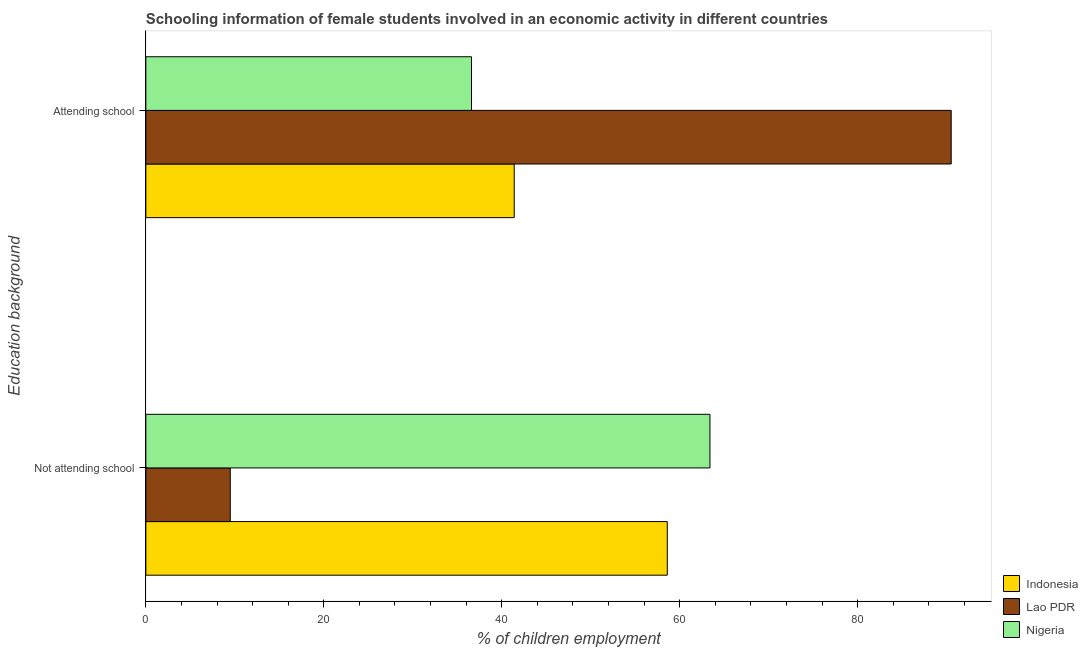How many different coloured bars are there?
Offer a very short reply. 3. How many groups of bars are there?
Your response must be concise. 2. Are the number of bars on each tick of the Y-axis equal?
Your response must be concise. Yes. What is the label of the 1st group of bars from the top?
Make the answer very short. Attending school. What is the percentage of employed females who are attending school in Nigeria?
Keep it short and to the point. 36.6. Across all countries, what is the maximum percentage of employed females who are attending school?
Offer a terse response. 90.51. Across all countries, what is the minimum percentage of employed females who are not attending school?
Make the answer very short. 9.49. In which country was the percentage of employed females who are attending school maximum?
Offer a very short reply. Lao PDR. In which country was the percentage of employed females who are attending school minimum?
Your answer should be compact. Nigeria. What is the total percentage of employed females who are attending school in the graph?
Your response must be concise. 168.51. What is the difference between the percentage of employed females who are not attending school in Nigeria and that in Lao PDR?
Offer a terse response. 53.91. What is the difference between the percentage of employed females who are attending school in Nigeria and the percentage of employed females who are not attending school in Indonesia?
Provide a short and direct response. -22. What is the average percentage of employed females who are not attending school per country?
Offer a very short reply. 43.83. What is the difference between the percentage of employed females who are attending school and percentage of employed females who are not attending school in Lao PDR?
Ensure brevity in your answer.  81.02. In how many countries, is the percentage of employed females who are attending school greater than 12 %?
Your answer should be compact. 3. What is the ratio of the percentage of employed females who are not attending school in Indonesia to that in Nigeria?
Ensure brevity in your answer.  0.92. In how many countries, is the percentage of employed females who are not attending school greater than the average percentage of employed females who are not attending school taken over all countries?
Keep it short and to the point. 2. What does the 3rd bar from the bottom in Attending school represents?
Give a very brief answer. Nigeria. How many countries are there in the graph?
Give a very brief answer. 3. Are the values on the major ticks of X-axis written in scientific E-notation?
Your response must be concise. No. What is the title of the graph?
Your answer should be very brief. Schooling information of female students involved in an economic activity in different countries. Does "Least developed countries" appear as one of the legend labels in the graph?
Provide a short and direct response. No. What is the label or title of the X-axis?
Give a very brief answer. % of children employment. What is the label or title of the Y-axis?
Make the answer very short. Education background. What is the % of children employment in Indonesia in Not attending school?
Provide a short and direct response. 58.6. What is the % of children employment in Lao PDR in Not attending school?
Your response must be concise. 9.49. What is the % of children employment in Nigeria in Not attending school?
Your response must be concise. 63.4. What is the % of children employment of Indonesia in Attending school?
Your answer should be compact. 41.4. What is the % of children employment in Lao PDR in Attending school?
Offer a terse response. 90.51. What is the % of children employment in Nigeria in Attending school?
Provide a succinct answer. 36.6. Across all Education background, what is the maximum % of children employment in Indonesia?
Make the answer very short. 58.6. Across all Education background, what is the maximum % of children employment of Lao PDR?
Give a very brief answer. 90.51. Across all Education background, what is the maximum % of children employment in Nigeria?
Make the answer very short. 63.4. Across all Education background, what is the minimum % of children employment in Indonesia?
Offer a terse response. 41.4. Across all Education background, what is the minimum % of children employment of Lao PDR?
Offer a terse response. 9.49. Across all Education background, what is the minimum % of children employment of Nigeria?
Keep it short and to the point. 36.6. What is the total % of children employment in Lao PDR in the graph?
Give a very brief answer. 100. What is the total % of children employment of Nigeria in the graph?
Your answer should be very brief. 100. What is the difference between the % of children employment of Indonesia in Not attending school and that in Attending school?
Give a very brief answer. 17.2. What is the difference between the % of children employment in Lao PDR in Not attending school and that in Attending school?
Give a very brief answer. -81.02. What is the difference between the % of children employment of Nigeria in Not attending school and that in Attending school?
Your answer should be very brief. 26.8. What is the difference between the % of children employment of Indonesia in Not attending school and the % of children employment of Lao PDR in Attending school?
Provide a short and direct response. -31.91. What is the difference between the % of children employment of Indonesia in Not attending school and the % of children employment of Nigeria in Attending school?
Ensure brevity in your answer.  22. What is the difference between the % of children employment in Lao PDR in Not attending school and the % of children employment in Nigeria in Attending school?
Your answer should be compact. -27.11. What is the average % of children employment in Nigeria per Education background?
Make the answer very short. 50. What is the difference between the % of children employment in Indonesia and % of children employment in Lao PDR in Not attending school?
Your answer should be compact. 49.11. What is the difference between the % of children employment of Lao PDR and % of children employment of Nigeria in Not attending school?
Your response must be concise. -53.91. What is the difference between the % of children employment of Indonesia and % of children employment of Lao PDR in Attending school?
Provide a short and direct response. -49.11. What is the difference between the % of children employment of Lao PDR and % of children employment of Nigeria in Attending school?
Ensure brevity in your answer.  53.91. What is the ratio of the % of children employment of Indonesia in Not attending school to that in Attending school?
Provide a succinct answer. 1.42. What is the ratio of the % of children employment in Lao PDR in Not attending school to that in Attending school?
Provide a short and direct response. 0.1. What is the ratio of the % of children employment in Nigeria in Not attending school to that in Attending school?
Your response must be concise. 1.73. What is the difference between the highest and the second highest % of children employment in Indonesia?
Provide a succinct answer. 17.2. What is the difference between the highest and the second highest % of children employment in Lao PDR?
Provide a short and direct response. 81.02. What is the difference between the highest and the second highest % of children employment of Nigeria?
Your answer should be compact. 26.8. What is the difference between the highest and the lowest % of children employment in Lao PDR?
Offer a terse response. 81.02. What is the difference between the highest and the lowest % of children employment of Nigeria?
Offer a terse response. 26.8. 